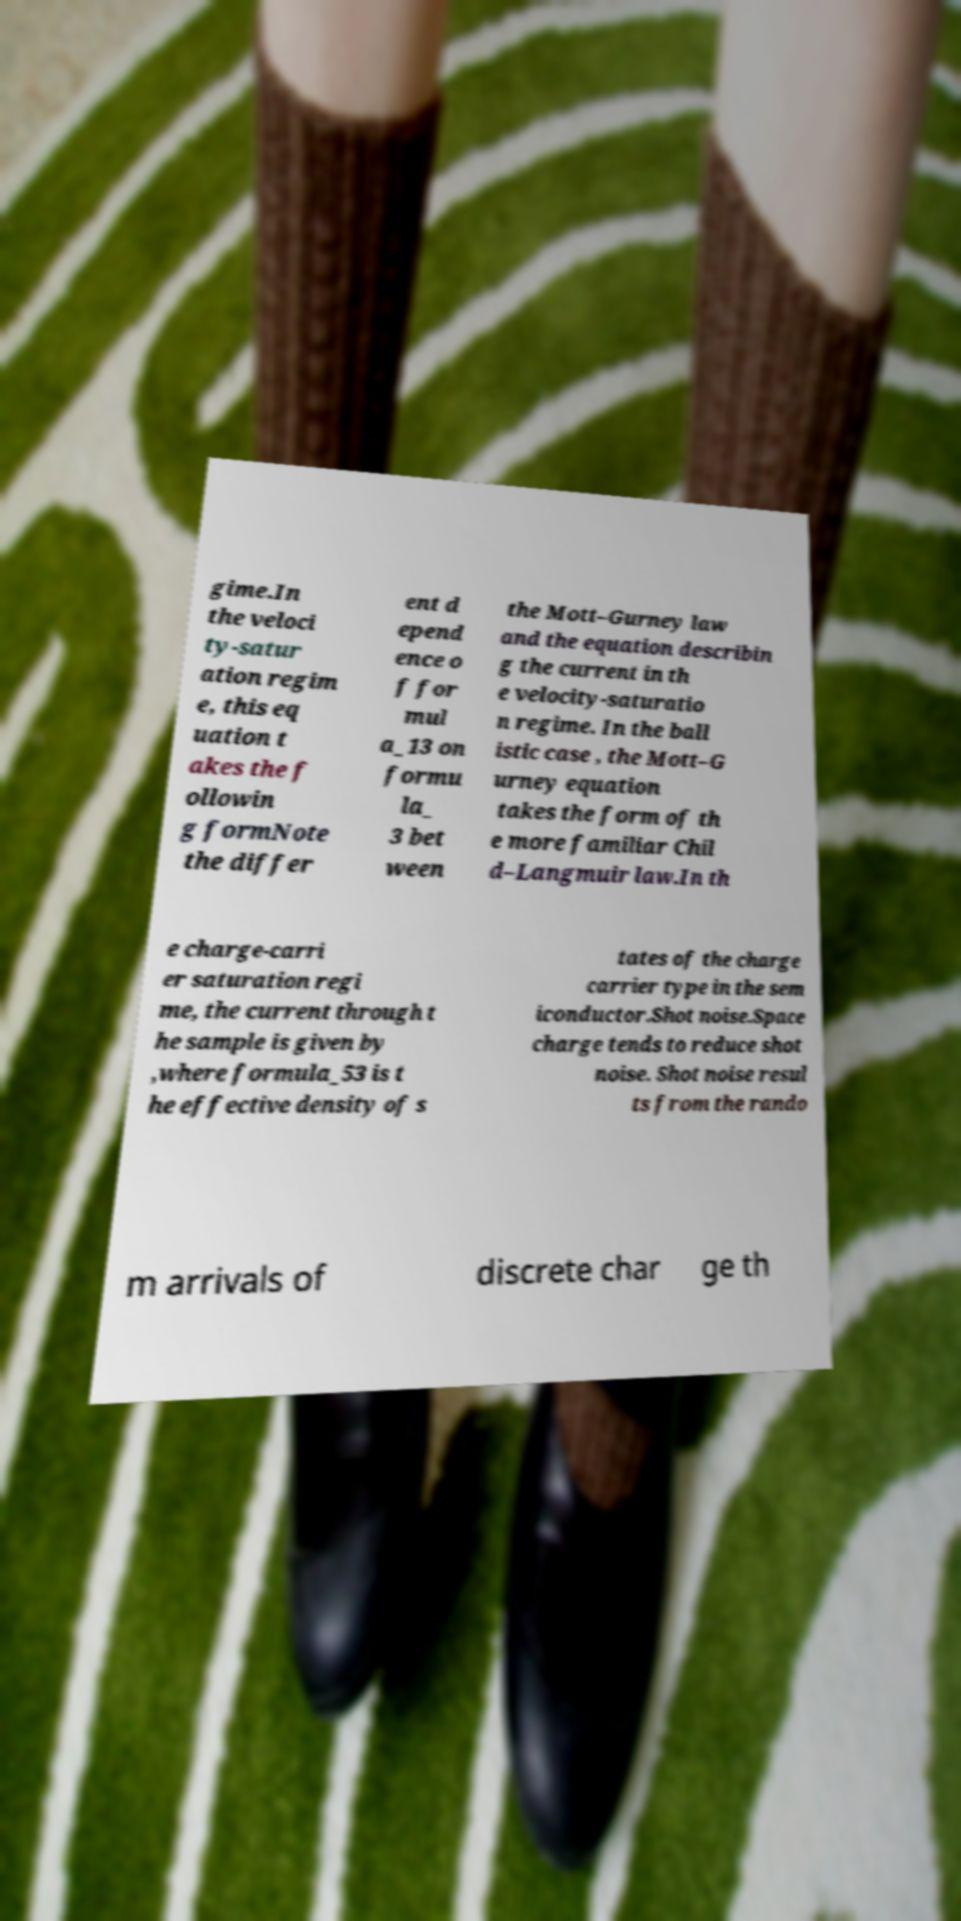What messages or text are displayed in this image? I need them in a readable, typed format. gime.In the veloci ty-satur ation regim e, this eq uation t akes the f ollowin g formNote the differ ent d epend ence o f for mul a_13 on formu la_ 3 bet ween the Mott–Gurney law and the equation describin g the current in th e velocity-saturatio n regime. In the ball istic case , the Mott–G urney equation takes the form of th e more familiar Chil d–Langmuir law.In th e charge-carri er saturation regi me, the current through t he sample is given by ,where formula_53 is t he effective density of s tates of the charge carrier type in the sem iconductor.Shot noise.Space charge tends to reduce shot noise. Shot noise resul ts from the rando m arrivals of discrete char ge th 